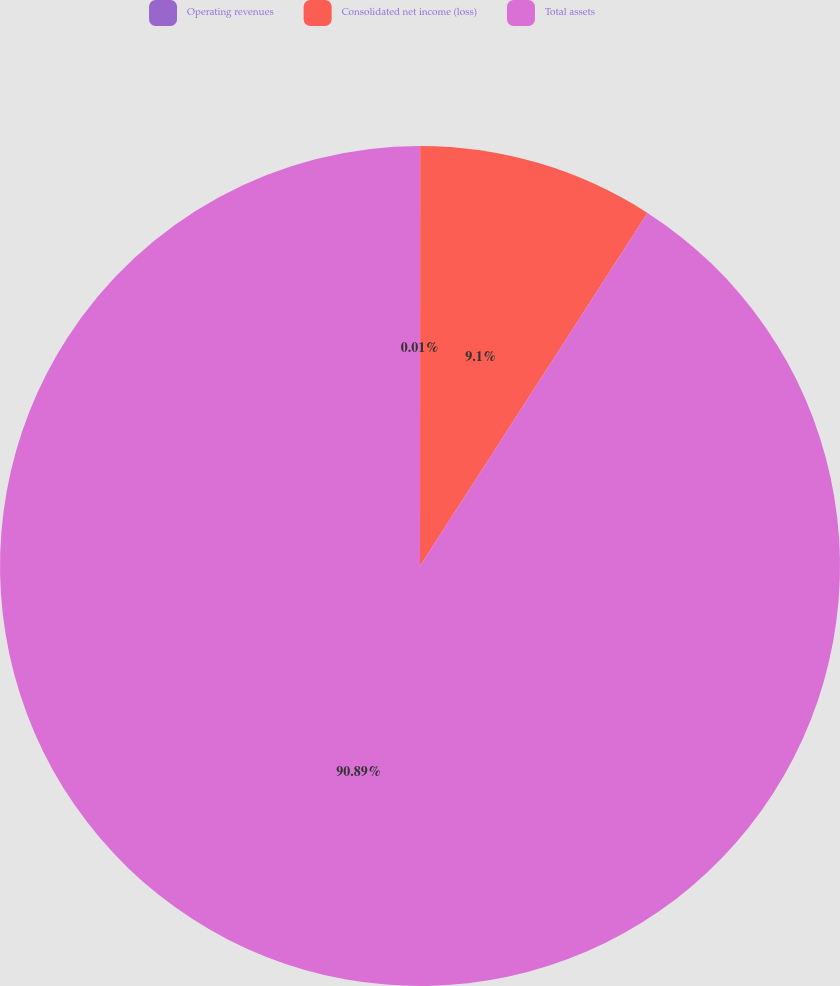Convert chart. <chart><loc_0><loc_0><loc_500><loc_500><pie_chart><fcel>Operating revenues<fcel>Consolidated net income (loss)<fcel>Total assets<nl><fcel>0.01%<fcel>9.1%<fcel>90.89%<nl></chart> 